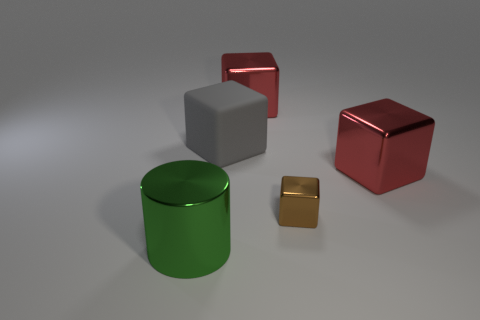What materials do the objects in the image appear to be made of? The objects present in the image appear to be rendered with different materials that resemble metals with varying reflective surfaces and colors, giving each item a distinct texture. Which object stands out the most and why? The green metallic cylinder stands out due to its distinct color which is different and more saturated than the other objects, as well as its central positioning in the image. 